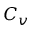<formula> <loc_0><loc_0><loc_500><loc_500>C _ { v }</formula> 